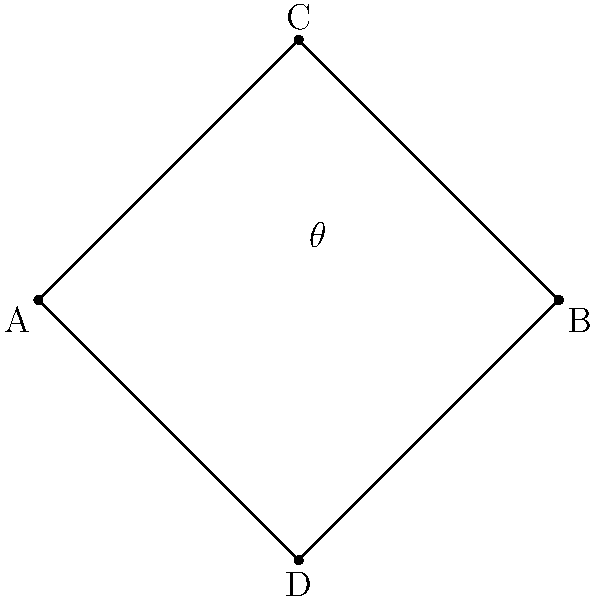In this diagram representing a cross, lines AC and BD intersect at right angles. If the angle between AC and AB is $\theta$, what is the value of $\tan \theta$? Let's approach this step-by-step:

1) In a right-angled triangle, $\tan \theta$ is defined as the ratio of the opposite side to the adjacent side.

2) In this case, we can focus on the right-angled triangle ABC:
   - The angle we're interested in is at point A.
   - The opposite side to this angle is BC.
   - The adjacent side is AB.

3) To find $\tan \theta$, we need to calculate $\frac{BC}{AB}$.

4) From the diagram:
   - AB is half the width of the cross, which is 2 units.
   - BC is half the height of the cross, which is also 2 units.

5) Therefore, $\tan \theta = \frac{BC}{AB} = \frac{2}{2} = 1$

This result reminds us of the biblical principle of balance and equality, as mentioned in Proverbs 11:1, "A false balance is an abomination to the Lord, but a just weight is his delight."
Answer: $1$ 